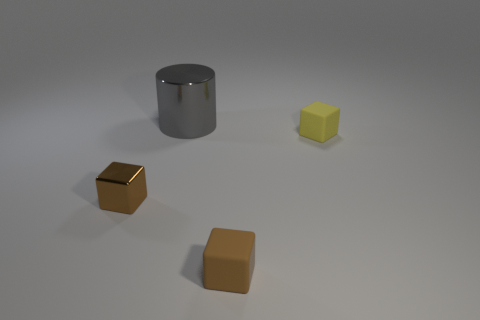Subtract all small yellow cubes. How many cubes are left? 2 Add 2 yellow things. How many objects exist? 6 Subtract all yellow cubes. How many cubes are left? 2 Subtract all green spheres. How many brown cubes are left? 2 Subtract 1 cubes. How many cubes are left? 2 Subtract all cylinders. How many objects are left? 3 Add 1 big shiny objects. How many big shiny objects exist? 2 Subtract 0 red balls. How many objects are left? 4 Subtract all yellow cylinders. Subtract all yellow balls. How many cylinders are left? 1 Subtract all red metal balls. Subtract all tiny yellow rubber blocks. How many objects are left? 3 